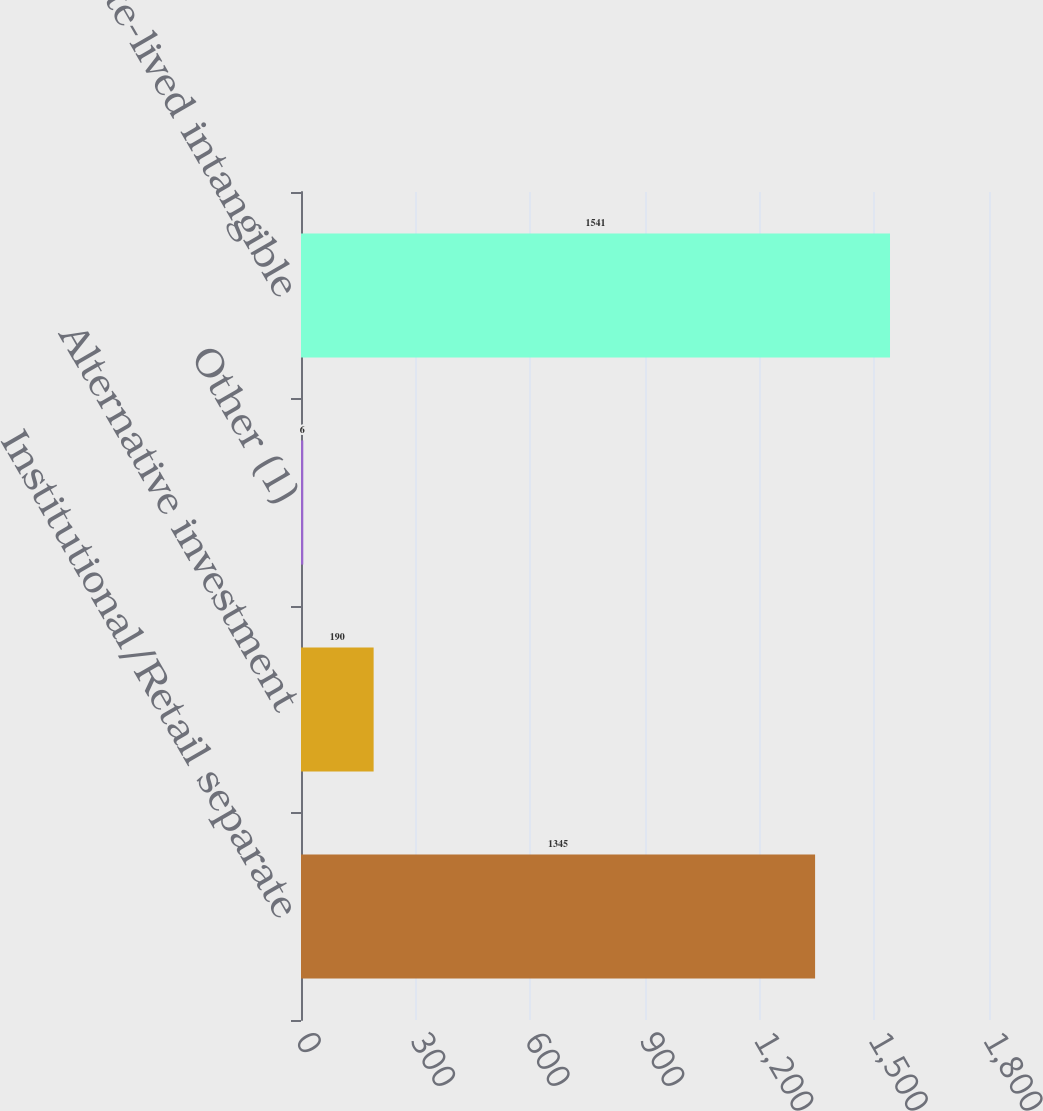<chart> <loc_0><loc_0><loc_500><loc_500><bar_chart><fcel>Institutional/Retail separate<fcel>Alternative investment<fcel>Other (1)<fcel>Total finite-lived intangible<nl><fcel>1345<fcel>190<fcel>6<fcel>1541<nl></chart> 